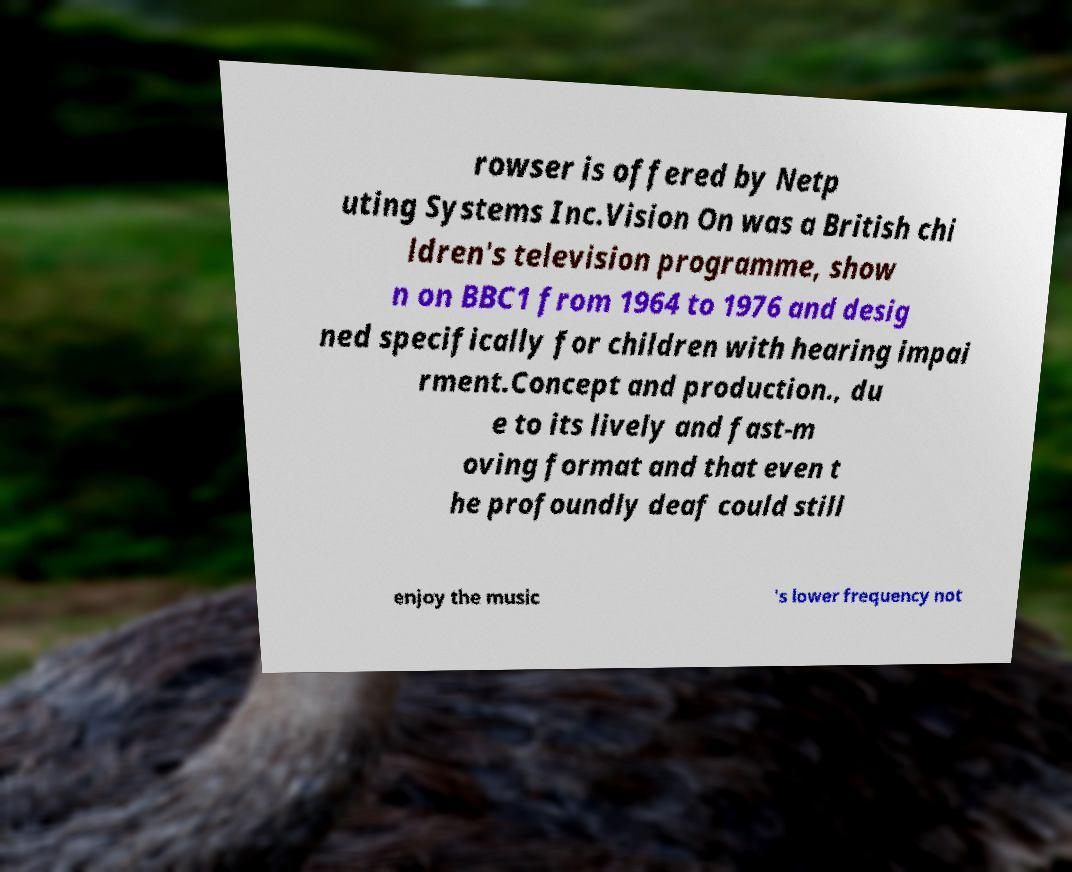Could you assist in decoding the text presented in this image and type it out clearly? rowser is offered by Netp uting Systems Inc.Vision On was a British chi ldren's television programme, show n on BBC1 from 1964 to 1976 and desig ned specifically for children with hearing impai rment.Concept and production., du e to its lively and fast-m oving format and that even t he profoundly deaf could still enjoy the music 's lower frequency not 